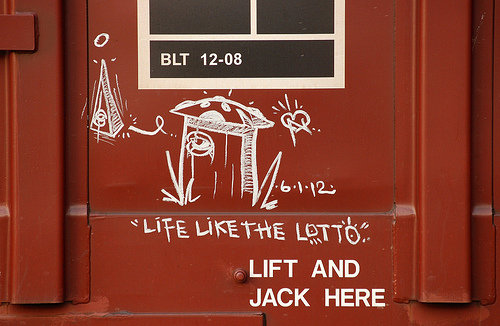<image>
Can you confirm if the drawing is on the wall? Yes. Looking at the image, I can see the drawing is positioned on top of the wall, with the wall providing support. 